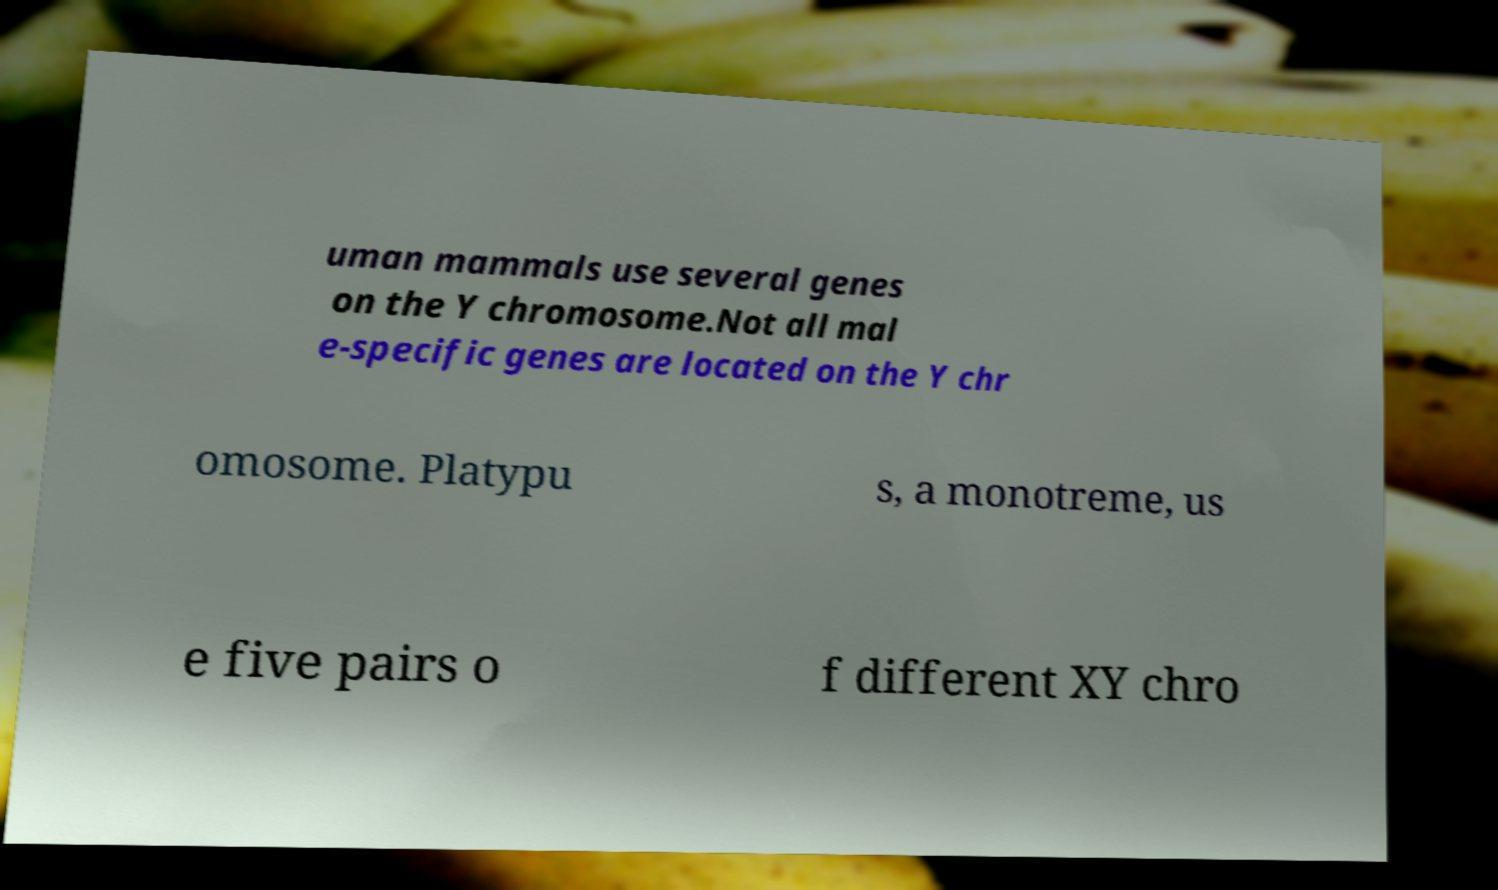Can you accurately transcribe the text from the provided image for me? uman mammals use several genes on the Y chromosome.Not all mal e-specific genes are located on the Y chr omosome. Platypu s, a monotreme, us e five pairs o f different XY chro 